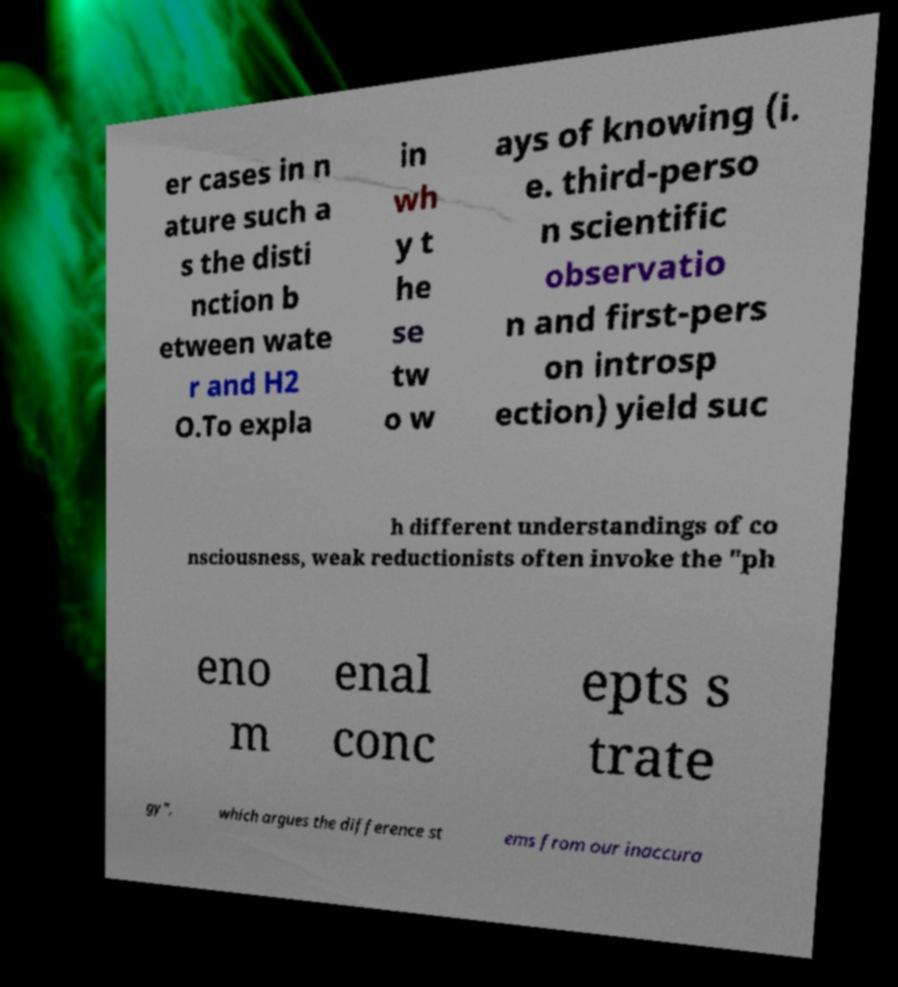There's text embedded in this image that I need extracted. Can you transcribe it verbatim? er cases in n ature such a s the disti nction b etween wate r and H2 O.To expla in wh y t he se tw o w ays of knowing (i. e. third-perso n scientific observatio n and first-pers on introsp ection) yield suc h different understandings of co nsciousness, weak reductionists often invoke the "ph eno m enal conc epts s trate gy", which argues the difference st ems from our inaccura 